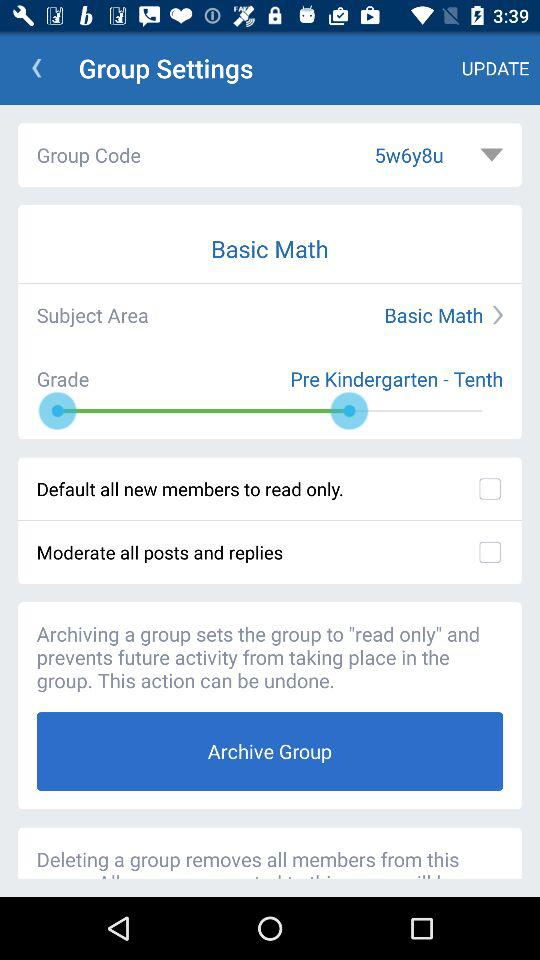What's the subject area? The subject area is "Basic Math". 